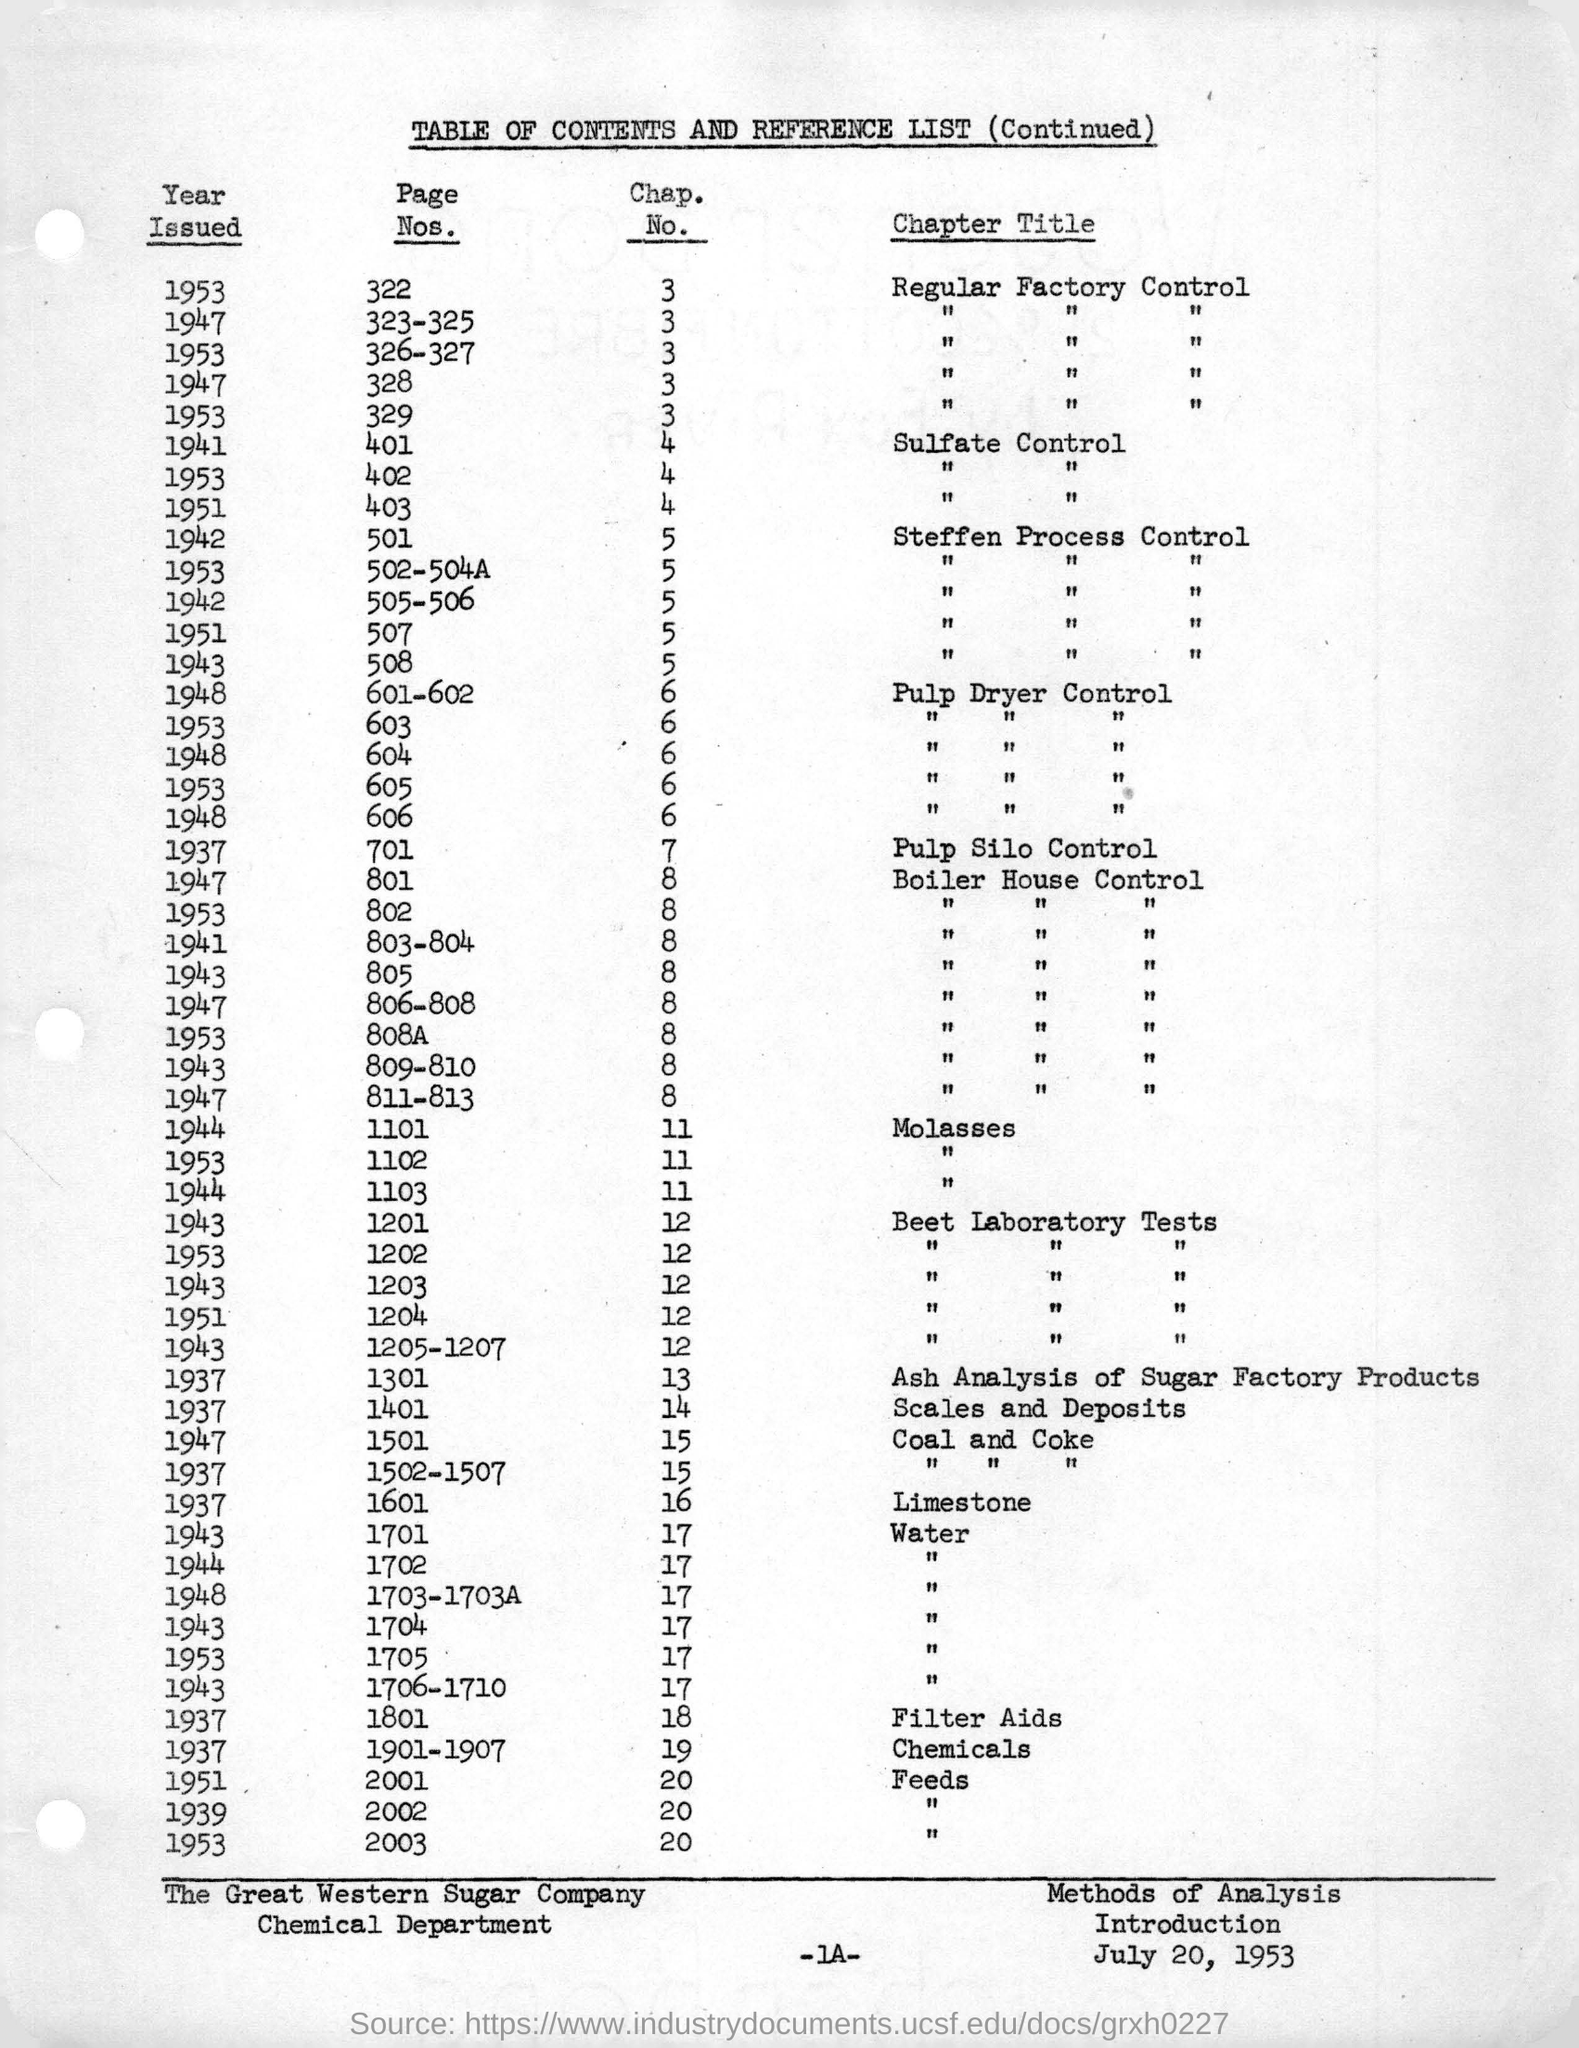Which is the issued year of Pulp Silo Control?
Offer a very short reply. 1937. Which Chapter of Filter Aids is issued on the year 1937?
Provide a succinct answer. 18. What is the date mentioned in the footer?
Keep it short and to the point. July 20, 1953. 